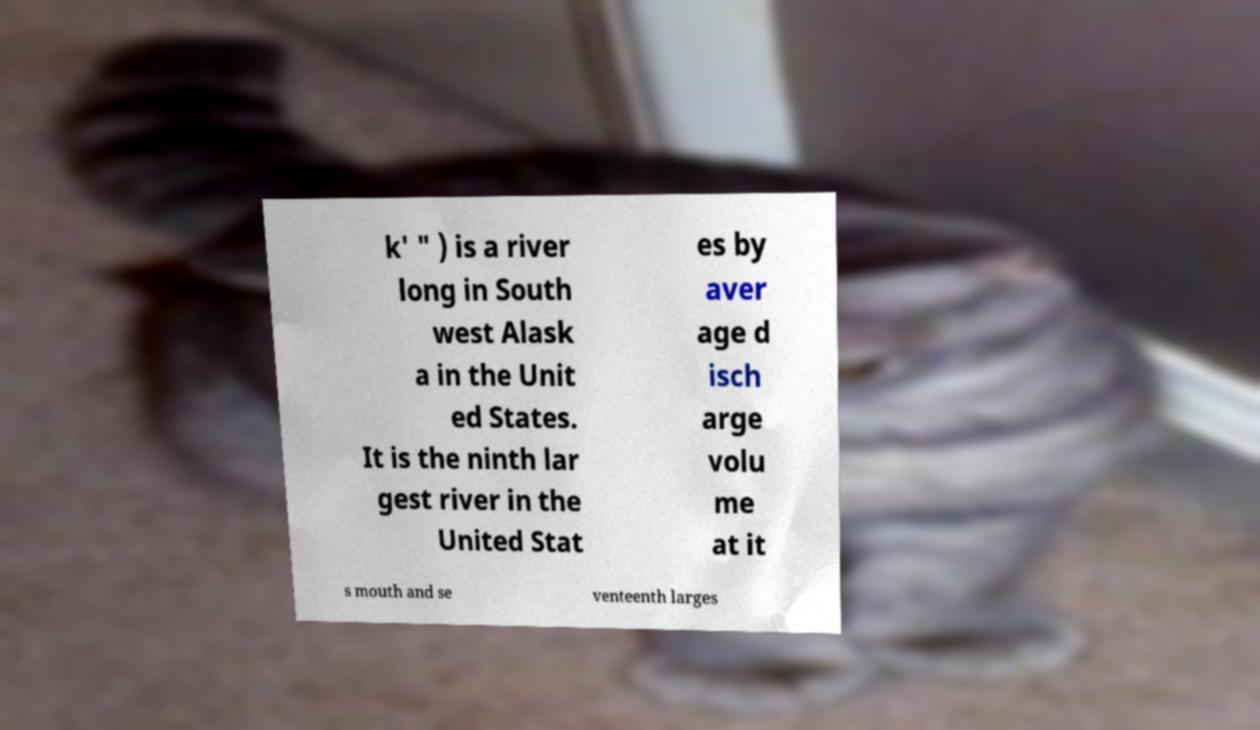Please read and relay the text visible in this image. What does it say? k' " ) is a river long in South west Alask a in the Unit ed States. It is the ninth lar gest river in the United Stat es by aver age d isch arge volu me at it s mouth and se venteenth larges 